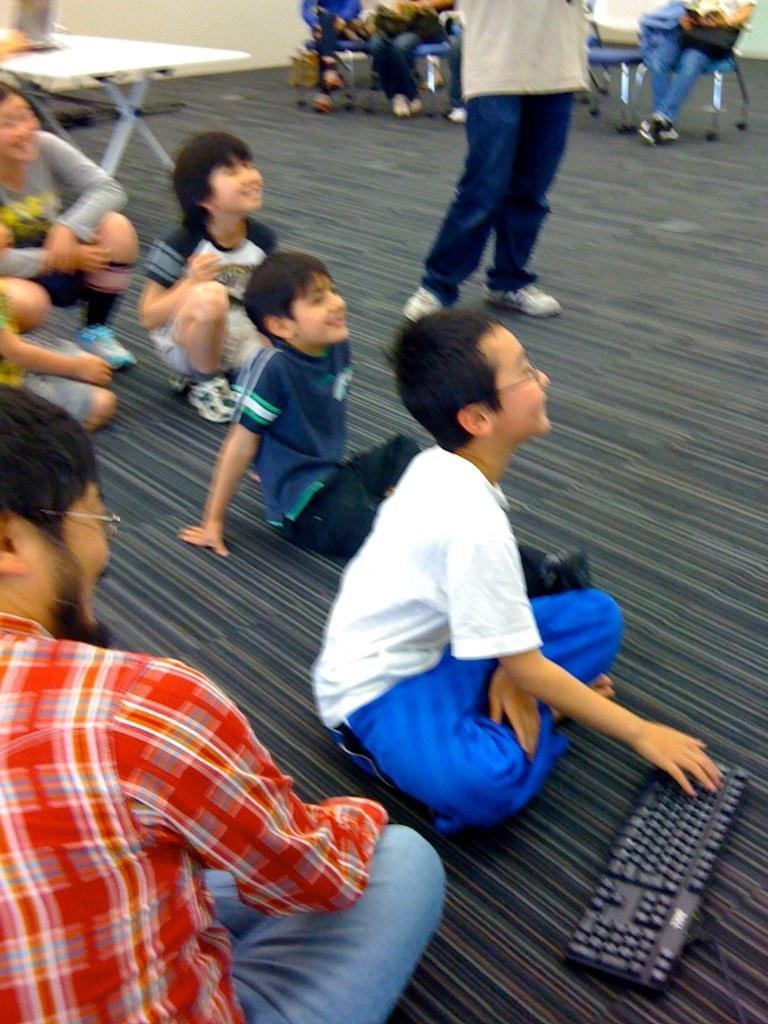Can you describe this image briefly? In this image e can see some group of persons, kids sitting on the floor and in the background of the image there are some persons sitting on chairs, in the foreground of the image there is a keyboard and background there is a table and wall. 